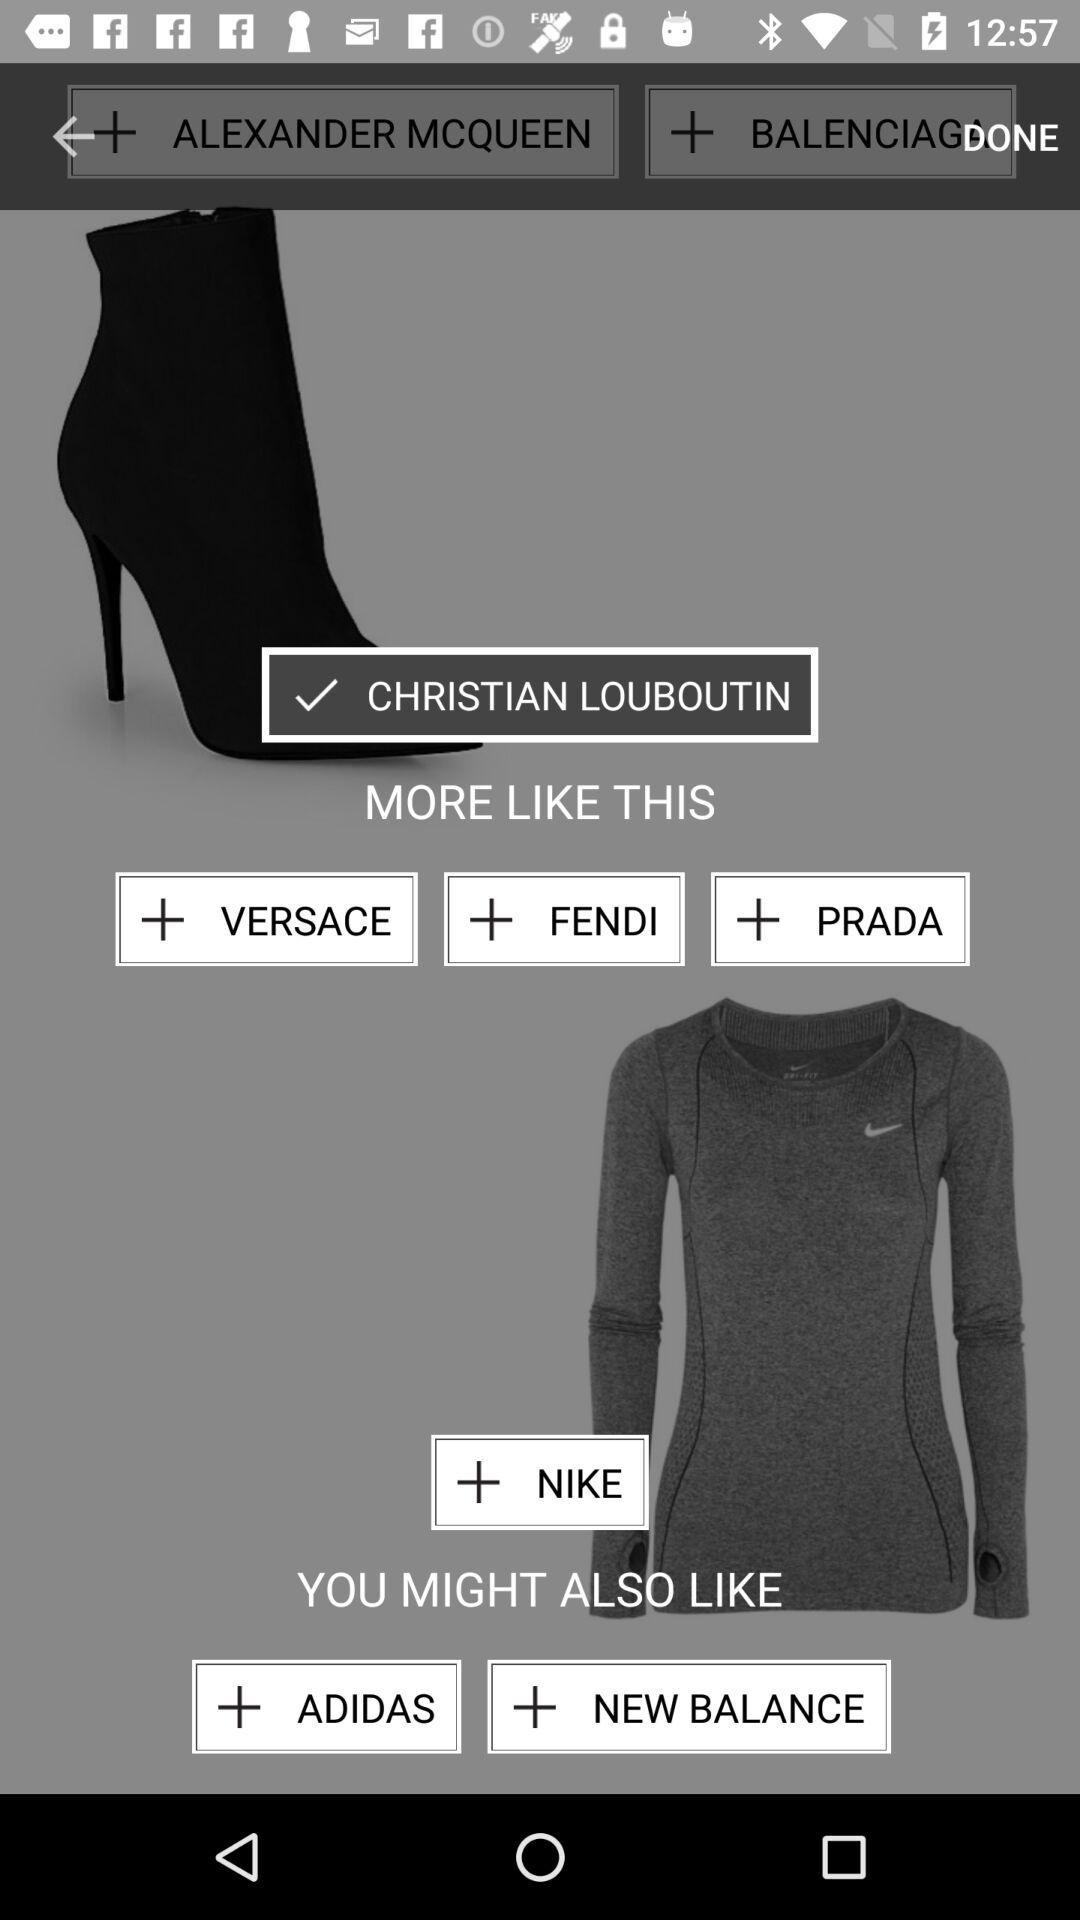What are the options in "MORE LIKE THIS"? The options in "MORE LIKE THIS" are "VERSACE", "FENDI" and "PRADA". 